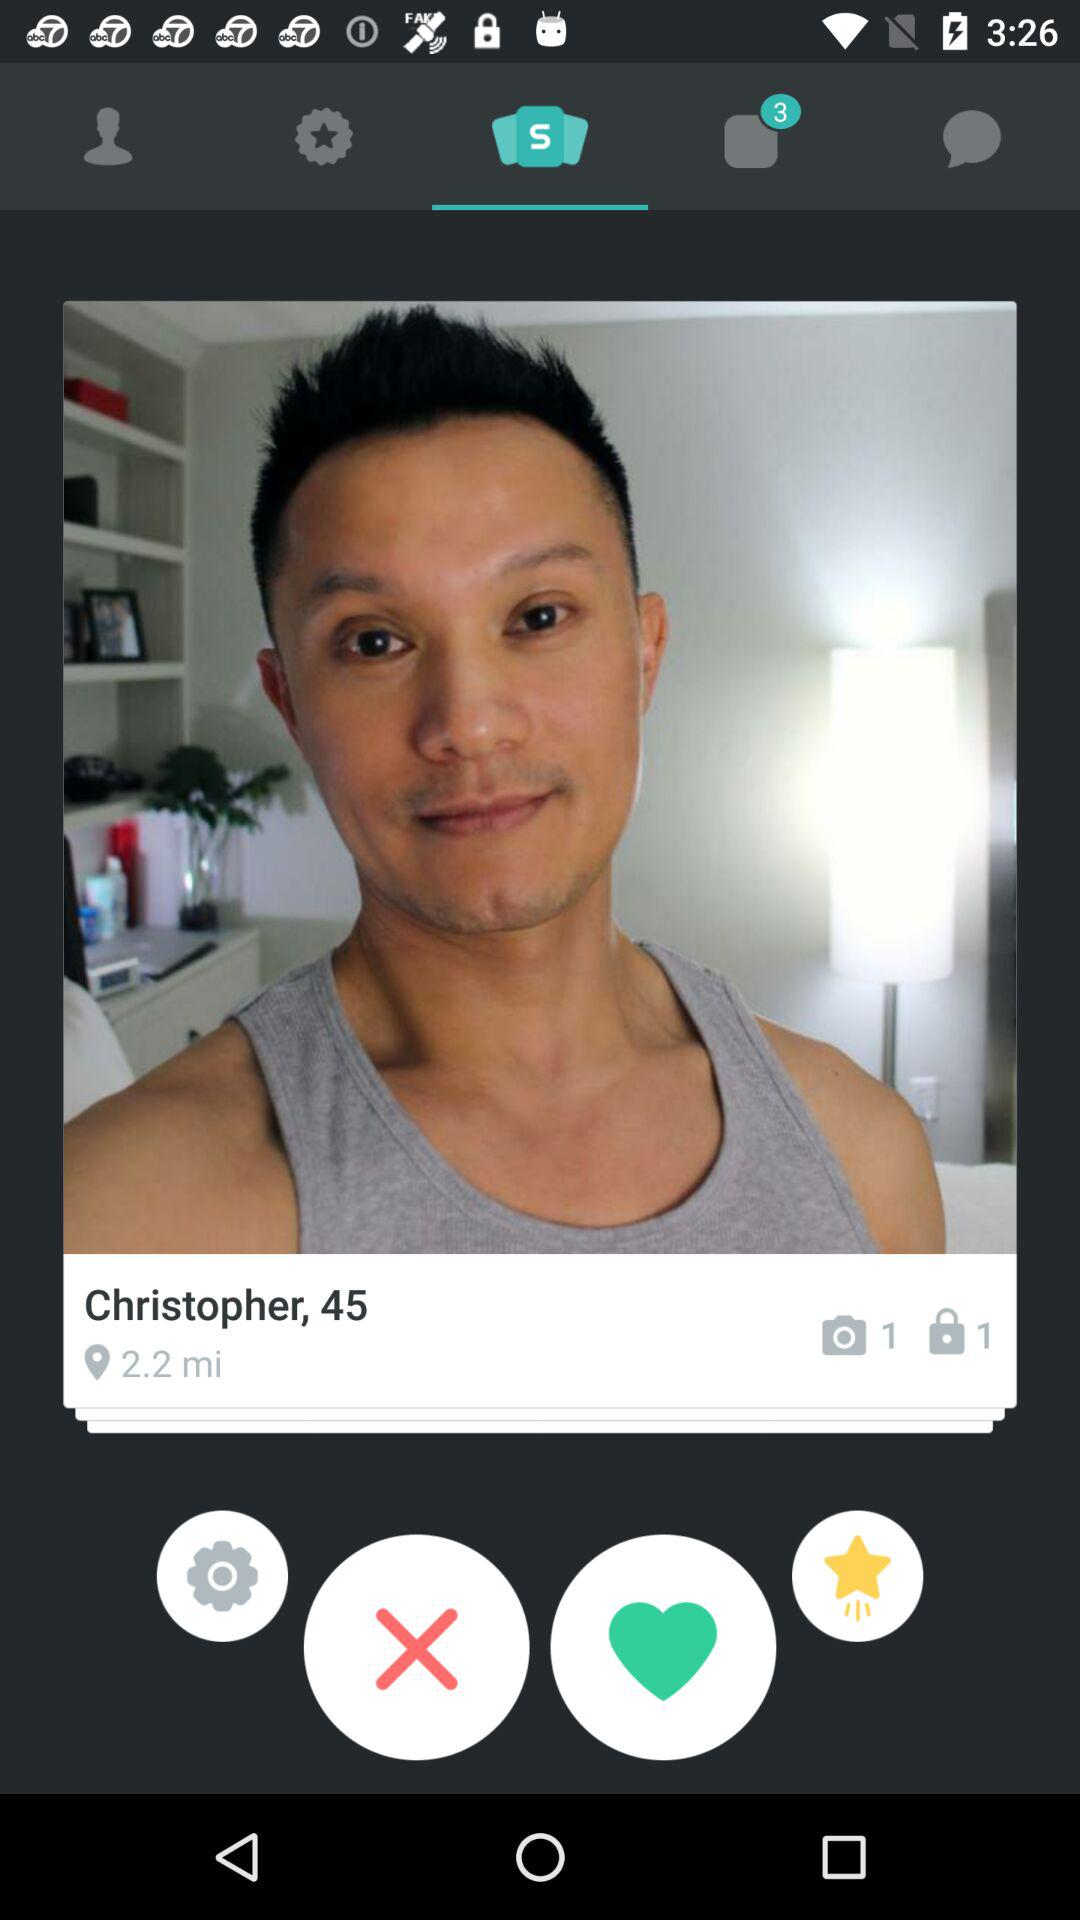How many camera photos are there? There is 1 camera photo. 